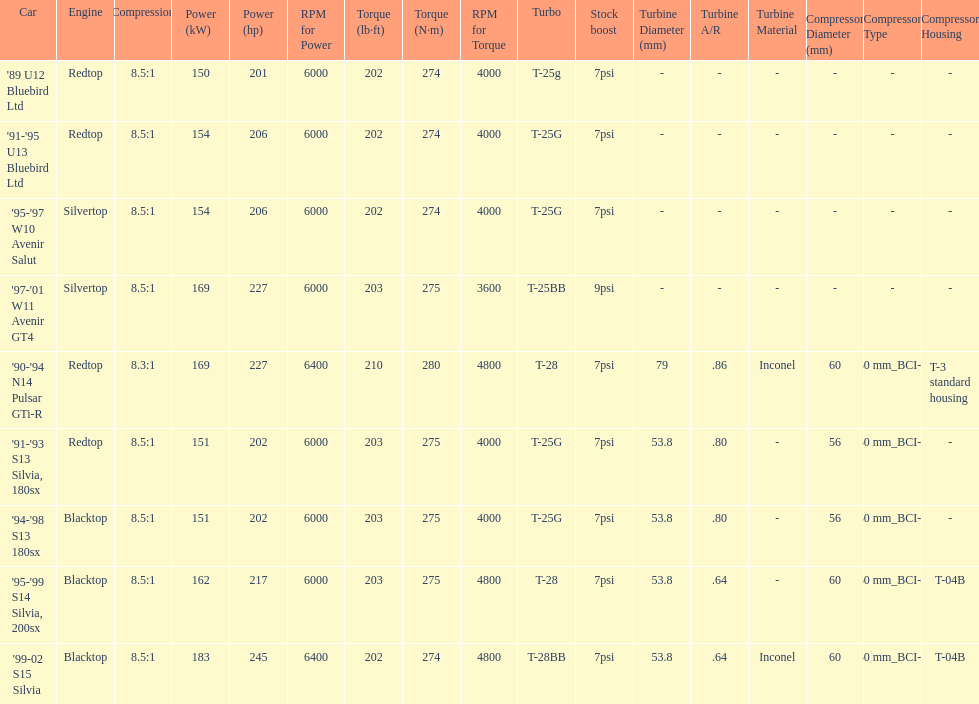Which engine(s) has the least amount of power? Redtop. 